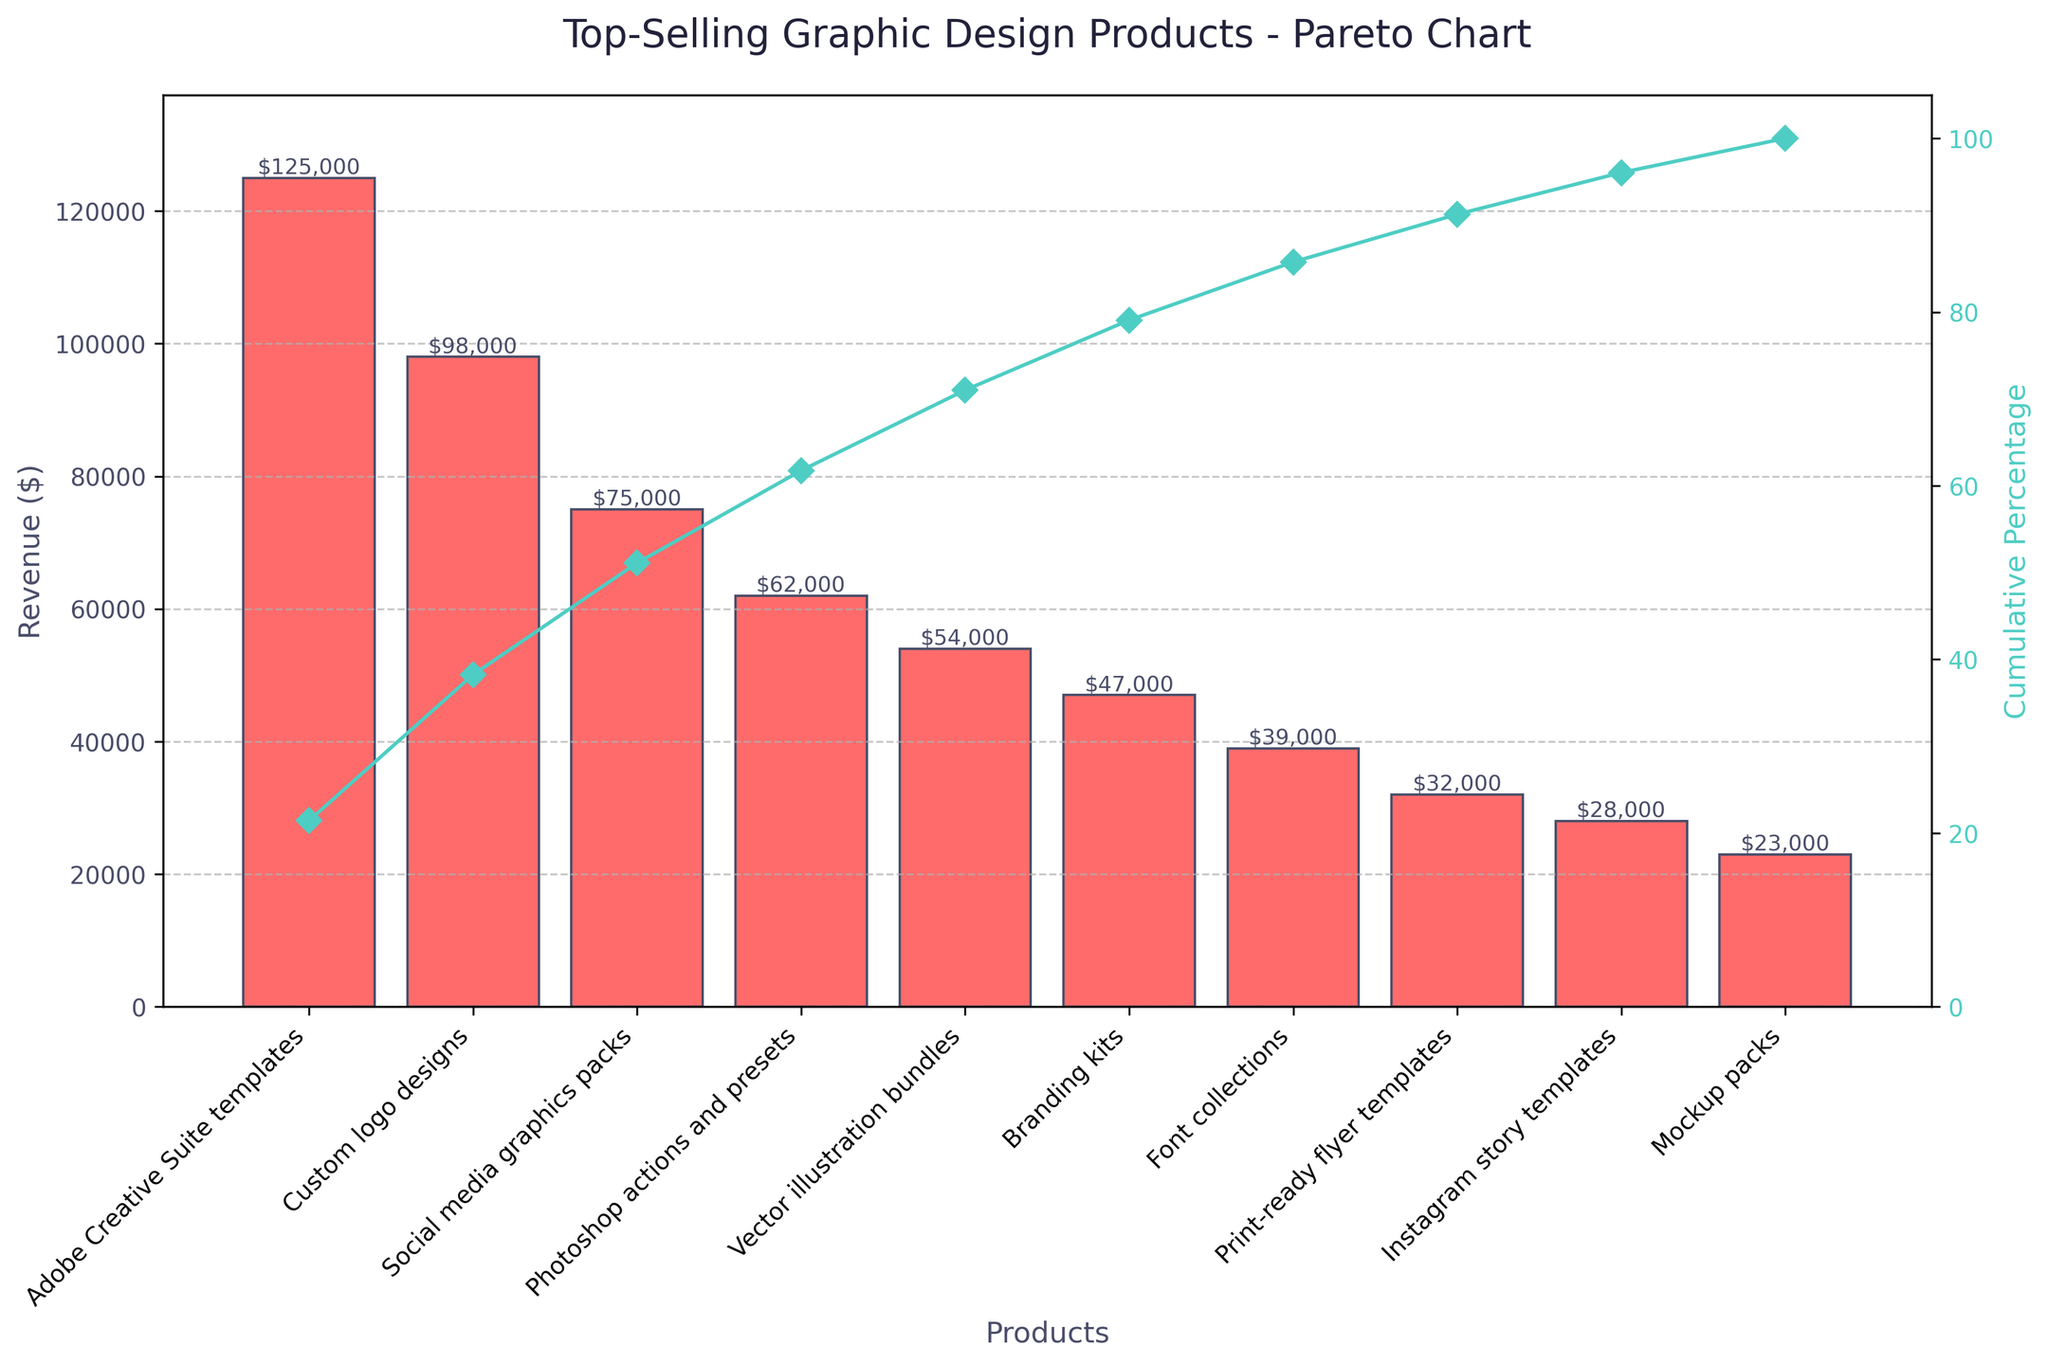what is the title of the chart? The title of the chart is shown at the top. It reads "Top-Selling Graphic Design Products - Pareto Chart".
Answer: Top-Selling Graphic Design Products - Pareto Chart Which product generated the highest revenue? Look at the highest bar on the chart. The label at the bottom of this bar will tell you the product name. The highest bar corresponds to "Adobe Creative Suite templates".
Answer: Adobe Creative Suite templates What's the combined revenue of the top three products? Look at the first three bars from left to right. The revenues are $125,000, $98,000, and $75,000. Adding these together gives $125,000 + $98,000 + $75,000 = $298,000.
Answer: $298,000 Which product sits exactly at 50% cumulative percentage? Look at the line showing the cumulative percentage. Find the point where it crosses the 50% mark on the right y-axis. The product corresponding to this point is "Photoshop actions and presets."
Answer: Photoshop actions and presets What percentage of total revenue is generated by the top five products? Add up the revenues of the top five products: $125,000 (Adobe Creative Suite templates) + $98,000 (Custom logo designs) + $75,000 (Social media graphics packs) + $62,000 (Photoshop actions and presets) + $54,000 (Vector illustration bundles) = $414,000. Then calculate this as a percentage of the total revenue, which is $524,000. ($414,000 / $524,000) * 100 ≈ 79%.
Answer: 79% Compare the revenue generated by "Vector illustration bundles" and "Branding kits". The bar for "Vector illustration bundles" is higher than the bar for "Branding kits". Specifically, "Vector illustration bundles" generated $54,000 while "Branding kits" generated $47,000.
Answer: "Vector illustration bundles" generated more revenue than "Branding kits" How many products contributed more than $50,000 in revenue each? Look at the bars representing the products and count those with heights exceeding the $50,000 mark on the y-axis. These are: "Adobe Creative Suite templates", "Custom logo designs", "Social media graphics packs", "Photoshop actions and presets", and "Vector illustration bundles". This makes a total of 5 products.
Answer: 5 products How much more revenue did "Custom logo designs" generate compared to "Photoshop actions and presets"? Find the revenues for both products. "Custom logo designs" generated $98,000 and "Photoshop actions and presets" generated $62,000. The difference is $98,000 - $62,000 = $36,000.
Answer: $36,000 What is the cumulative percentage at the product "Mockup packs"? Follow the cumulative percentage curve to the point corresponding to "Mockup packs". The height at this point on the right y-axis indicates the percentage. It is approximately at the 90% mark.
Answer: Approximately 90% What does the color of the bars and line represent in the chart? The color of the bars represents revenue in dollars, and the line color represents the cumulative percentage of total revenue. The bars are colored a reddish shade and the line is a teal color.
Answer: Revenue and Cumulative Percentage 